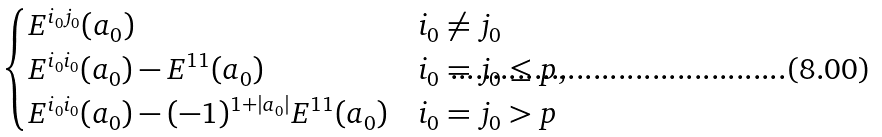Convert formula to latex. <formula><loc_0><loc_0><loc_500><loc_500>\begin{cases} E ^ { i _ { 0 } j _ { 0 } } ( a _ { 0 } ) & i _ { 0 } \neq j _ { 0 } \\ E ^ { i _ { 0 } i _ { 0 } } ( a _ { 0 } ) - E ^ { 1 1 } ( a _ { 0 } ) & i _ { 0 } = j _ { 0 } \leq p , \\ E ^ { i _ { 0 } i _ { 0 } } ( a _ { 0 } ) - ( - 1 ) ^ { 1 + | a _ { 0 } | } E ^ { 1 1 } ( a _ { 0 } ) & i _ { 0 } = j _ { 0 } > p \end{cases}</formula> 